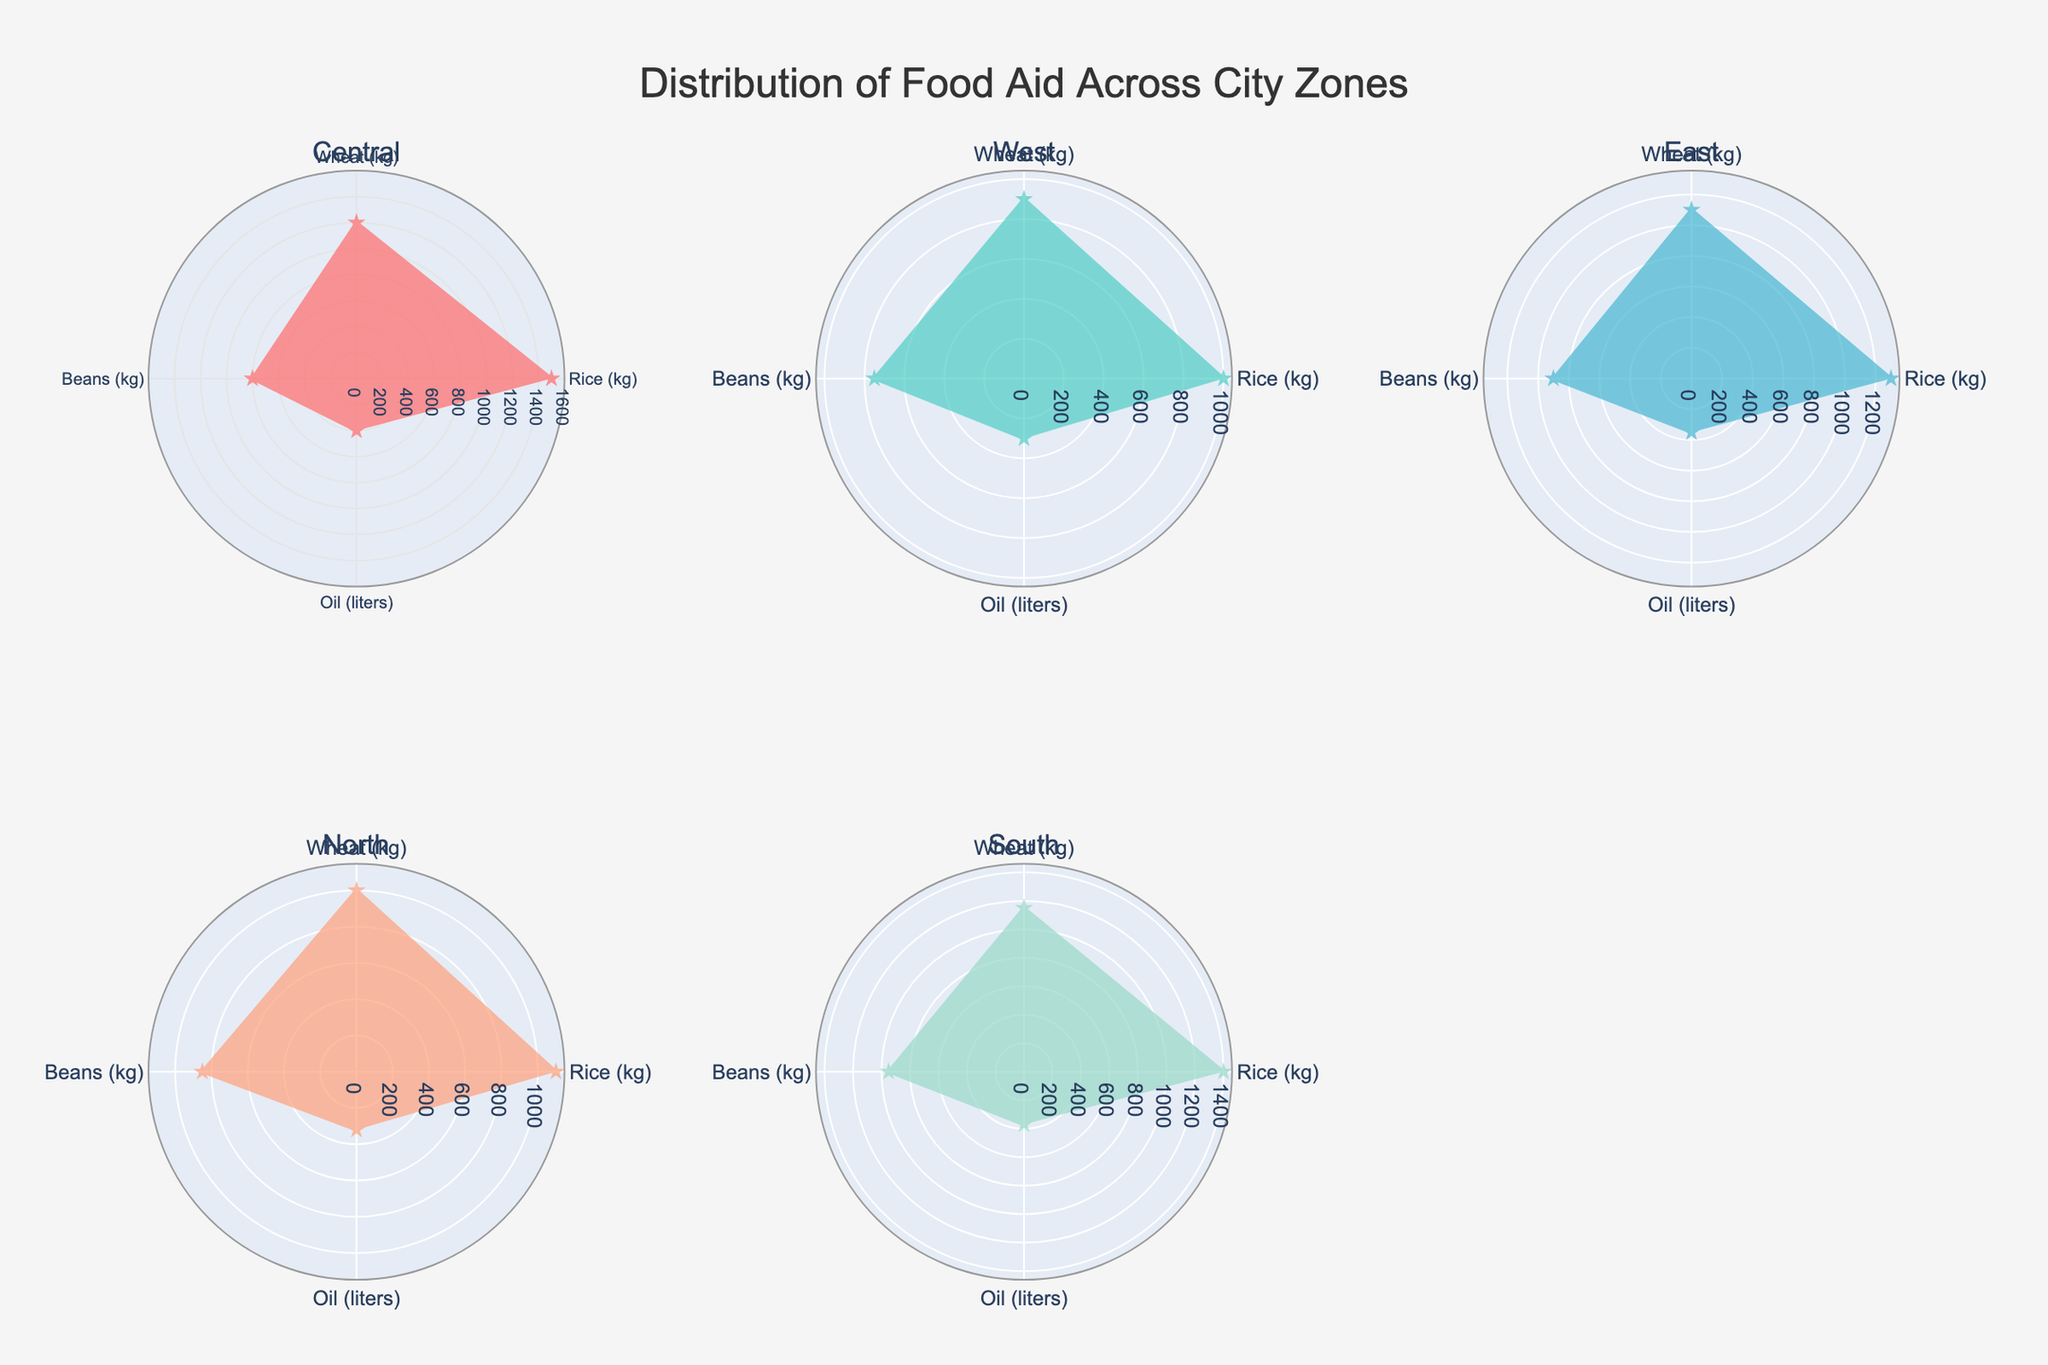Which zone received the highest amount of Rice aid? Look for the data point on the polar charts with the largest radius (value) under the 'Rice (kg)' category for each zone. Zone A shows the highest value.
Answer: Zone A Which food staple has the lowest distribution in Zone B? Compare the lengths of the radius for all food staples (Rice, Wheat, Beans, Oil) for Zone B. Oil has the shortest radius in Zone B.
Answer: Oil What is the difference in Wheat aid between Zone C and Zone D? Note the Wheat (kg) values for both zones from the chart. Zone C has 1100 kg and Zone D has 1000 kg of Wheat. Calculate the difference as 1100 - 1000.
Answer: 100 kg Which zone has the most balanced distribution of all food staples? Look for the polar chart where all food staple segments (Rice, Wheat, Beans, Oil) are similar in length, indicating a balanced distribution. Zone D shows relatively similar lengths for all categories.
Answer: Zone D Between Rice and Beans, which food staple shows the greatest difference in distribution across zones? Compare the lengths of the segments for Rice and Beans across all zones. Rice distribution varies the most from 1000 kg to 1500 kg, while Beans vary from 750 kg to 950 kg.
Answer: Rice What is the total amount of Oil distributed among all zones? Sum the Oil (liters) values for all zones: 400 (Zone A) + 300 (Zone B) + 350 (Zone C) + 320 (Zone D) + 370 (Zone E). This results in 400 + 300 + 350 + 320 + 370 = 1740 liters.
Answer: 1740 liters How does Zone E's distribution of Beans compare to Zone A's Beans distribution? Look at the lengths of the Beans (kg) segments for Zone E and Zone A. Zone E has 950 kg, and Zone A has 800 kg. Zone E's Beans distribution is higher by 150 kg.
Answer: Zone E's is greater Among the zones, which one has the smallest difference between Rice and Wheat distribution? Calculate the difference between Rice (kg) and Wheat (kg) for each zone and find which zone has the smallest difference: Zone A (1500-1200), Zone B (1000-900), Zone C (1300-1100), Zone D (1100-1000), Zone E (1400-1150). Zone B has the smallest difference of 100 kg.
Answer: Zone B What percentage of the total Rice distributed is allocated to Zone C? First, sum the Rice (kg) values for all zones: 1500 + 1000 + 1300 + 1100 + 1400 = 6300 kg. Then, find Zone C's proportion: (1300 / 6300) * 100 ≈ 20.63%.
Answer: 20.63% Which zones received more Rice aid than Oil aid? Compare the lengths of the 'Rice' segments and 'Oil' segments for each zone to determine which zones received more Rice than Oil. Zones A, B, C, D, and E all have their Rice segments longer than their Oil segments.
Answer: All zones 